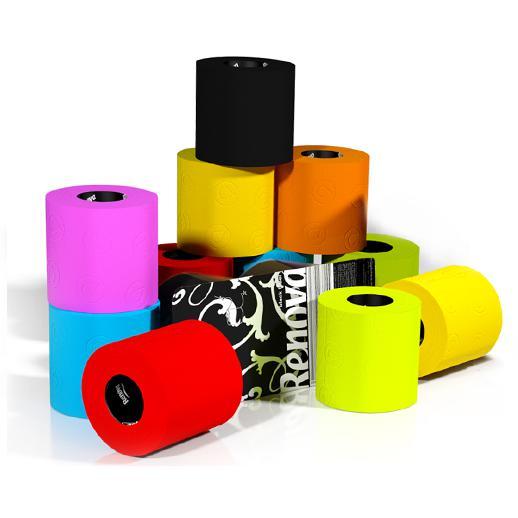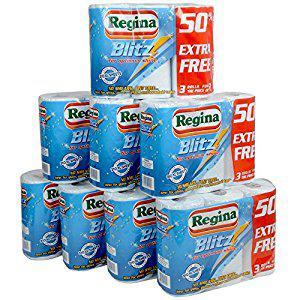The first image is the image on the left, the second image is the image on the right. Assess this claim about the two images: "In at least one image there are two or more rolls of paper towels in each package.". Correct or not? Answer yes or no. Yes. The first image is the image on the left, the second image is the image on the right. For the images shown, is this caption "One of the roll of paper towels is not in its wrapper." true? Answer yes or no. No. 